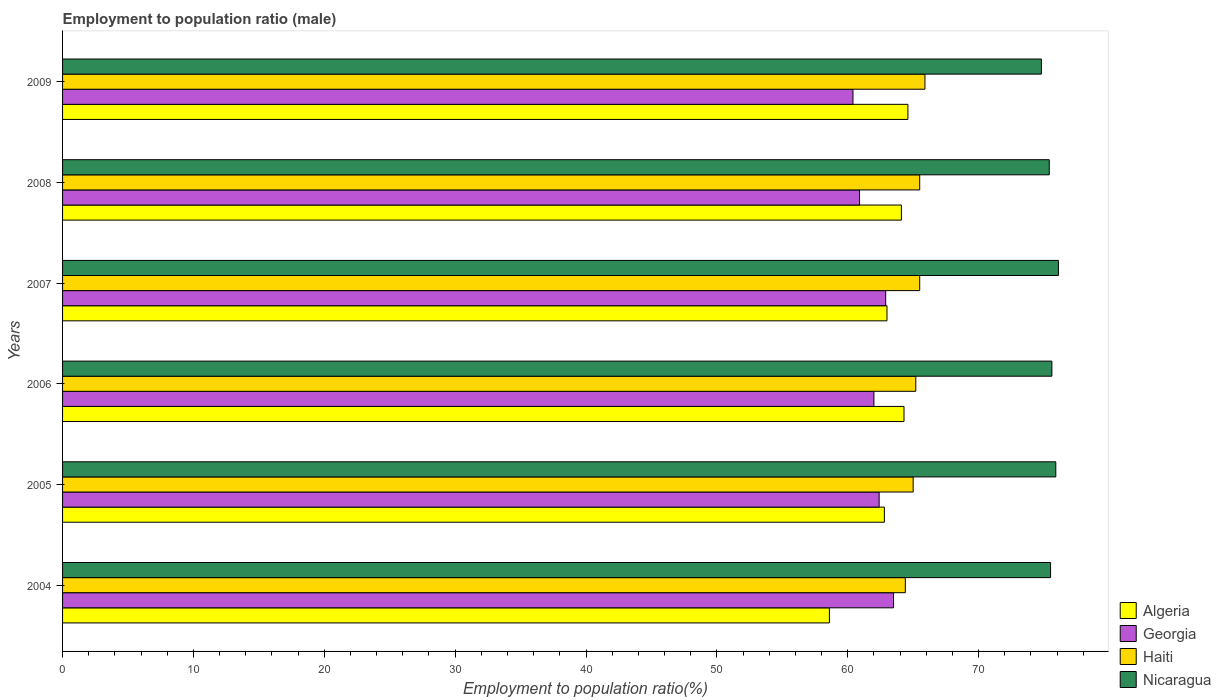How many different coloured bars are there?
Provide a short and direct response. 4. Are the number of bars per tick equal to the number of legend labels?
Ensure brevity in your answer.  Yes. What is the label of the 2nd group of bars from the top?
Make the answer very short. 2008. What is the employment to population ratio in Georgia in 2008?
Keep it short and to the point. 60.9. Across all years, what is the maximum employment to population ratio in Georgia?
Your response must be concise. 63.5. Across all years, what is the minimum employment to population ratio in Haiti?
Ensure brevity in your answer.  64.4. In which year was the employment to population ratio in Haiti maximum?
Ensure brevity in your answer.  2009. In which year was the employment to population ratio in Georgia minimum?
Ensure brevity in your answer.  2009. What is the total employment to population ratio in Algeria in the graph?
Make the answer very short. 377.4. What is the difference between the employment to population ratio in Nicaragua in 2004 and that in 2005?
Your answer should be very brief. -0.4. What is the difference between the employment to population ratio in Georgia in 2006 and the employment to population ratio in Nicaragua in 2005?
Keep it short and to the point. -13.9. What is the average employment to population ratio in Haiti per year?
Your response must be concise. 65.25. In the year 2005, what is the difference between the employment to population ratio in Haiti and employment to population ratio in Nicaragua?
Your answer should be very brief. -10.9. What is the ratio of the employment to population ratio in Algeria in 2007 to that in 2009?
Give a very brief answer. 0.98. Is the employment to population ratio in Georgia in 2004 less than that in 2008?
Your answer should be compact. No. Is the difference between the employment to population ratio in Haiti in 2006 and 2009 greater than the difference between the employment to population ratio in Nicaragua in 2006 and 2009?
Your answer should be compact. No. What is the difference between the highest and the second highest employment to population ratio in Haiti?
Your answer should be compact. 0.4. What is the difference between the highest and the lowest employment to population ratio in Georgia?
Your answer should be compact. 3.1. In how many years, is the employment to population ratio in Georgia greater than the average employment to population ratio in Georgia taken over all years?
Your response must be concise. 3. What does the 3rd bar from the top in 2006 represents?
Provide a succinct answer. Georgia. What does the 2nd bar from the bottom in 2007 represents?
Ensure brevity in your answer.  Georgia. Is it the case that in every year, the sum of the employment to population ratio in Haiti and employment to population ratio in Nicaragua is greater than the employment to population ratio in Georgia?
Give a very brief answer. Yes. Are all the bars in the graph horizontal?
Provide a short and direct response. Yes. Are the values on the major ticks of X-axis written in scientific E-notation?
Provide a short and direct response. No. How many legend labels are there?
Your response must be concise. 4. How are the legend labels stacked?
Your answer should be very brief. Vertical. What is the title of the graph?
Offer a very short reply. Employment to population ratio (male). What is the label or title of the X-axis?
Keep it short and to the point. Employment to population ratio(%). What is the label or title of the Y-axis?
Offer a terse response. Years. What is the Employment to population ratio(%) of Algeria in 2004?
Your response must be concise. 58.6. What is the Employment to population ratio(%) in Georgia in 2004?
Offer a very short reply. 63.5. What is the Employment to population ratio(%) of Haiti in 2004?
Ensure brevity in your answer.  64.4. What is the Employment to population ratio(%) of Nicaragua in 2004?
Make the answer very short. 75.5. What is the Employment to population ratio(%) in Algeria in 2005?
Your response must be concise. 62.8. What is the Employment to population ratio(%) of Georgia in 2005?
Offer a very short reply. 62.4. What is the Employment to population ratio(%) of Nicaragua in 2005?
Your answer should be very brief. 75.9. What is the Employment to population ratio(%) of Algeria in 2006?
Provide a succinct answer. 64.3. What is the Employment to population ratio(%) of Georgia in 2006?
Offer a terse response. 62. What is the Employment to population ratio(%) in Haiti in 2006?
Your response must be concise. 65.2. What is the Employment to population ratio(%) in Nicaragua in 2006?
Your answer should be compact. 75.6. What is the Employment to population ratio(%) of Algeria in 2007?
Your response must be concise. 63. What is the Employment to population ratio(%) in Georgia in 2007?
Make the answer very short. 62.9. What is the Employment to population ratio(%) of Haiti in 2007?
Your answer should be compact. 65.5. What is the Employment to population ratio(%) in Nicaragua in 2007?
Your response must be concise. 76.1. What is the Employment to population ratio(%) in Algeria in 2008?
Keep it short and to the point. 64.1. What is the Employment to population ratio(%) in Georgia in 2008?
Provide a short and direct response. 60.9. What is the Employment to population ratio(%) in Haiti in 2008?
Provide a short and direct response. 65.5. What is the Employment to population ratio(%) in Nicaragua in 2008?
Your answer should be very brief. 75.4. What is the Employment to population ratio(%) of Algeria in 2009?
Provide a succinct answer. 64.6. What is the Employment to population ratio(%) of Georgia in 2009?
Make the answer very short. 60.4. What is the Employment to population ratio(%) in Haiti in 2009?
Ensure brevity in your answer.  65.9. What is the Employment to population ratio(%) in Nicaragua in 2009?
Provide a succinct answer. 74.8. Across all years, what is the maximum Employment to population ratio(%) in Algeria?
Your response must be concise. 64.6. Across all years, what is the maximum Employment to population ratio(%) in Georgia?
Keep it short and to the point. 63.5. Across all years, what is the maximum Employment to population ratio(%) of Haiti?
Ensure brevity in your answer.  65.9. Across all years, what is the maximum Employment to population ratio(%) in Nicaragua?
Keep it short and to the point. 76.1. Across all years, what is the minimum Employment to population ratio(%) of Algeria?
Provide a succinct answer. 58.6. Across all years, what is the minimum Employment to population ratio(%) in Georgia?
Your answer should be very brief. 60.4. Across all years, what is the minimum Employment to population ratio(%) in Haiti?
Give a very brief answer. 64.4. Across all years, what is the minimum Employment to population ratio(%) in Nicaragua?
Offer a terse response. 74.8. What is the total Employment to population ratio(%) in Algeria in the graph?
Provide a succinct answer. 377.4. What is the total Employment to population ratio(%) of Georgia in the graph?
Give a very brief answer. 372.1. What is the total Employment to population ratio(%) of Haiti in the graph?
Your answer should be compact. 391.5. What is the total Employment to population ratio(%) in Nicaragua in the graph?
Give a very brief answer. 453.3. What is the difference between the Employment to population ratio(%) in Georgia in 2004 and that in 2005?
Ensure brevity in your answer.  1.1. What is the difference between the Employment to population ratio(%) in Nicaragua in 2004 and that in 2005?
Make the answer very short. -0.4. What is the difference between the Employment to population ratio(%) in Haiti in 2004 and that in 2006?
Provide a short and direct response. -0.8. What is the difference between the Employment to population ratio(%) in Nicaragua in 2004 and that in 2006?
Your answer should be compact. -0.1. What is the difference between the Employment to population ratio(%) of Algeria in 2004 and that in 2008?
Give a very brief answer. -5.5. What is the difference between the Employment to population ratio(%) of Georgia in 2004 and that in 2009?
Keep it short and to the point. 3.1. What is the difference between the Employment to population ratio(%) in Haiti in 2004 and that in 2009?
Offer a terse response. -1.5. What is the difference between the Employment to population ratio(%) in Nicaragua in 2004 and that in 2009?
Offer a very short reply. 0.7. What is the difference between the Employment to population ratio(%) of Nicaragua in 2005 and that in 2006?
Provide a short and direct response. 0.3. What is the difference between the Employment to population ratio(%) in Algeria in 2005 and that in 2008?
Offer a very short reply. -1.3. What is the difference between the Employment to population ratio(%) of Algeria in 2005 and that in 2009?
Keep it short and to the point. -1.8. What is the difference between the Employment to population ratio(%) in Georgia in 2006 and that in 2007?
Provide a succinct answer. -0.9. What is the difference between the Employment to population ratio(%) of Haiti in 2006 and that in 2007?
Your response must be concise. -0.3. What is the difference between the Employment to population ratio(%) in Nicaragua in 2006 and that in 2007?
Make the answer very short. -0.5. What is the difference between the Employment to population ratio(%) in Haiti in 2006 and that in 2008?
Offer a terse response. -0.3. What is the difference between the Employment to population ratio(%) in Algeria in 2006 and that in 2009?
Your answer should be compact. -0.3. What is the difference between the Employment to population ratio(%) of Haiti in 2006 and that in 2009?
Keep it short and to the point. -0.7. What is the difference between the Employment to population ratio(%) of Nicaragua in 2006 and that in 2009?
Keep it short and to the point. 0.8. What is the difference between the Employment to population ratio(%) of Georgia in 2007 and that in 2008?
Your answer should be compact. 2. What is the difference between the Employment to population ratio(%) of Georgia in 2007 and that in 2009?
Offer a very short reply. 2.5. What is the difference between the Employment to population ratio(%) of Haiti in 2007 and that in 2009?
Offer a very short reply. -0.4. What is the difference between the Employment to population ratio(%) of Nicaragua in 2007 and that in 2009?
Give a very brief answer. 1.3. What is the difference between the Employment to population ratio(%) in Algeria in 2008 and that in 2009?
Provide a succinct answer. -0.5. What is the difference between the Employment to population ratio(%) of Georgia in 2008 and that in 2009?
Offer a terse response. 0.5. What is the difference between the Employment to population ratio(%) of Nicaragua in 2008 and that in 2009?
Offer a terse response. 0.6. What is the difference between the Employment to population ratio(%) in Algeria in 2004 and the Employment to population ratio(%) in Nicaragua in 2005?
Ensure brevity in your answer.  -17.3. What is the difference between the Employment to population ratio(%) of Algeria in 2004 and the Employment to population ratio(%) of Georgia in 2006?
Make the answer very short. -3.4. What is the difference between the Employment to population ratio(%) of Algeria in 2004 and the Employment to population ratio(%) of Haiti in 2006?
Your answer should be compact. -6.6. What is the difference between the Employment to population ratio(%) of Georgia in 2004 and the Employment to population ratio(%) of Nicaragua in 2006?
Offer a terse response. -12.1. What is the difference between the Employment to population ratio(%) in Algeria in 2004 and the Employment to population ratio(%) in Haiti in 2007?
Make the answer very short. -6.9. What is the difference between the Employment to population ratio(%) of Algeria in 2004 and the Employment to population ratio(%) of Nicaragua in 2007?
Ensure brevity in your answer.  -17.5. What is the difference between the Employment to population ratio(%) of Georgia in 2004 and the Employment to population ratio(%) of Haiti in 2007?
Your response must be concise. -2. What is the difference between the Employment to population ratio(%) in Haiti in 2004 and the Employment to population ratio(%) in Nicaragua in 2007?
Ensure brevity in your answer.  -11.7. What is the difference between the Employment to population ratio(%) of Algeria in 2004 and the Employment to population ratio(%) of Nicaragua in 2008?
Provide a succinct answer. -16.8. What is the difference between the Employment to population ratio(%) of Georgia in 2004 and the Employment to population ratio(%) of Haiti in 2008?
Ensure brevity in your answer.  -2. What is the difference between the Employment to population ratio(%) in Georgia in 2004 and the Employment to population ratio(%) in Nicaragua in 2008?
Make the answer very short. -11.9. What is the difference between the Employment to population ratio(%) in Algeria in 2004 and the Employment to population ratio(%) in Haiti in 2009?
Keep it short and to the point. -7.3. What is the difference between the Employment to population ratio(%) of Algeria in 2004 and the Employment to population ratio(%) of Nicaragua in 2009?
Make the answer very short. -16.2. What is the difference between the Employment to population ratio(%) in Georgia in 2004 and the Employment to population ratio(%) in Nicaragua in 2009?
Make the answer very short. -11.3. What is the difference between the Employment to population ratio(%) of Georgia in 2005 and the Employment to population ratio(%) of Haiti in 2006?
Offer a terse response. -2.8. What is the difference between the Employment to population ratio(%) in Georgia in 2005 and the Employment to population ratio(%) in Nicaragua in 2006?
Your response must be concise. -13.2. What is the difference between the Employment to population ratio(%) in Georgia in 2005 and the Employment to population ratio(%) in Haiti in 2007?
Keep it short and to the point. -3.1. What is the difference between the Employment to population ratio(%) of Georgia in 2005 and the Employment to population ratio(%) of Nicaragua in 2007?
Ensure brevity in your answer.  -13.7. What is the difference between the Employment to population ratio(%) in Haiti in 2005 and the Employment to population ratio(%) in Nicaragua in 2007?
Offer a terse response. -11.1. What is the difference between the Employment to population ratio(%) of Algeria in 2005 and the Employment to population ratio(%) of Georgia in 2008?
Offer a terse response. 1.9. What is the difference between the Employment to population ratio(%) in Algeria in 2005 and the Employment to population ratio(%) in Haiti in 2008?
Offer a terse response. -2.7. What is the difference between the Employment to population ratio(%) of Algeria in 2005 and the Employment to population ratio(%) of Nicaragua in 2008?
Provide a short and direct response. -12.6. What is the difference between the Employment to population ratio(%) in Georgia in 2005 and the Employment to population ratio(%) in Haiti in 2008?
Offer a very short reply. -3.1. What is the difference between the Employment to population ratio(%) in Georgia in 2005 and the Employment to population ratio(%) in Nicaragua in 2008?
Your answer should be very brief. -13. What is the difference between the Employment to population ratio(%) in Haiti in 2005 and the Employment to population ratio(%) in Nicaragua in 2008?
Your answer should be compact. -10.4. What is the difference between the Employment to population ratio(%) in Algeria in 2005 and the Employment to population ratio(%) in Georgia in 2009?
Your answer should be compact. 2.4. What is the difference between the Employment to population ratio(%) in Algeria in 2005 and the Employment to population ratio(%) in Haiti in 2009?
Provide a short and direct response. -3.1. What is the difference between the Employment to population ratio(%) of Georgia in 2005 and the Employment to population ratio(%) of Nicaragua in 2009?
Provide a succinct answer. -12.4. What is the difference between the Employment to population ratio(%) in Algeria in 2006 and the Employment to population ratio(%) in Georgia in 2007?
Offer a very short reply. 1.4. What is the difference between the Employment to population ratio(%) in Algeria in 2006 and the Employment to population ratio(%) in Nicaragua in 2007?
Offer a very short reply. -11.8. What is the difference between the Employment to population ratio(%) of Georgia in 2006 and the Employment to population ratio(%) of Haiti in 2007?
Provide a succinct answer. -3.5. What is the difference between the Employment to population ratio(%) in Georgia in 2006 and the Employment to population ratio(%) in Nicaragua in 2007?
Ensure brevity in your answer.  -14.1. What is the difference between the Employment to population ratio(%) in Haiti in 2006 and the Employment to population ratio(%) in Nicaragua in 2007?
Ensure brevity in your answer.  -10.9. What is the difference between the Employment to population ratio(%) in Algeria in 2006 and the Employment to population ratio(%) in Georgia in 2008?
Your answer should be very brief. 3.4. What is the difference between the Employment to population ratio(%) of Algeria in 2006 and the Employment to population ratio(%) of Nicaragua in 2008?
Provide a short and direct response. -11.1. What is the difference between the Employment to population ratio(%) of Georgia in 2006 and the Employment to population ratio(%) of Haiti in 2008?
Your response must be concise. -3.5. What is the difference between the Employment to population ratio(%) of Georgia in 2006 and the Employment to population ratio(%) of Nicaragua in 2008?
Your response must be concise. -13.4. What is the difference between the Employment to population ratio(%) of Georgia in 2006 and the Employment to population ratio(%) of Nicaragua in 2009?
Make the answer very short. -12.8. What is the difference between the Employment to population ratio(%) of Haiti in 2006 and the Employment to population ratio(%) of Nicaragua in 2009?
Ensure brevity in your answer.  -9.6. What is the difference between the Employment to population ratio(%) in Algeria in 2007 and the Employment to population ratio(%) in Georgia in 2008?
Keep it short and to the point. 2.1. What is the difference between the Employment to population ratio(%) in Algeria in 2007 and the Employment to population ratio(%) in Haiti in 2008?
Your response must be concise. -2.5. What is the difference between the Employment to population ratio(%) of Algeria in 2007 and the Employment to population ratio(%) of Nicaragua in 2008?
Provide a short and direct response. -12.4. What is the difference between the Employment to population ratio(%) in Georgia in 2007 and the Employment to population ratio(%) in Haiti in 2008?
Make the answer very short. -2.6. What is the difference between the Employment to population ratio(%) of Haiti in 2007 and the Employment to population ratio(%) of Nicaragua in 2008?
Provide a succinct answer. -9.9. What is the difference between the Employment to population ratio(%) of Algeria in 2007 and the Employment to population ratio(%) of Haiti in 2009?
Give a very brief answer. -2.9. What is the difference between the Employment to population ratio(%) of Algeria in 2007 and the Employment to population ratio(%) of Nicaragua in 2009?
Offer a terse response. -11.8. What is the difference between the Employment to population ratio(%) in Georgia in 2007 and the Employment to population ratio(%) in Haiti in 2009?
Offer a terse response. -3. What is the difference between the Employment to population ratio(%) of Georgia in 2007 and the Employment to population ratio(%) of Nicaragua in 2009?
Give a very brief answer. -11.9. What is the difference between the Employment to population ratio(%) in Georgia in 2008 and the Employment to population ratio(%) in Haiti in 2009?
Provide a succinct answer. -5. What is the difference between the Employment to population ratio(%) in Georgia in 2008 and the Employment to population ratio(%) in Nicaragua in 2009?
Offer a terse response. -13.9. What is the average Employment to population ratio(%) in Algeria per year?
Give a very brief answer. 62.9. What is the average Employment to population ratio(%) of Georgia per year?
Make the answer very short. 62.02. What is the average Employment to population ratio(%) in Haiti per year?
Your answer should be very brief. 65.25. What is the average Employment to population ratio(%) in Nicaragua per year?
Keep it short and to the point. 75.55. In the year 2004, what is the difference between the Employment to population ratio(%) of Algeria and Employment to population ratio(%) of Georgia?
Offer a terse response. -4.9. In the year 2004, what is the difference between the Employment to population ratio(%) in Algeria and Employment to population ratio(%) in Nicaragua?
Provide a succinct answer. -16.9. In the year 2004, what is the difference between the Employment to population ratio(%) of Georgia and Employment to population ratio(%) of Nicaragua?
Offer a terse response. -12. In the year 2005, what is the difference between the Employment to population ratio(%) in Algeria and Employment to population ratio(%) in Haiti?
Your response must be concise. -2.2. In the year 2005, what is the difference between the Employment to population ratio(%) of Algeria and Employment to population ratio(%) of Nicaragua?
Make the answer very short. -13.1. In the year 2005, what is the difference between the Employment to population ratio(%) in Georgia and Employment to population ratio(%) in Haiti?
Provide a short and direct response. -2.6. In the year 2005, what is the difference between the Employment to population ratio(%) in Georgia and Employment to population ratio(%) in Nicaragua?
Ensure brevity in your answer.  -13.5. In the year 2006, what is the difference between the Employment to population ratio(%) in Algeria and Employment to population ratio(%) in Georgia?
Keep it short and to the point. 2.3. In the year 2006, what is the difference between the Employment to population ratio(%) in Algeria and Employment to population ratio(%) in Haiti?
Offer a terse response. -0.9. In the year 2006, what is the difference between the Employment to population ratio(%) in Algeria and Employment to population ratio(%) in Nicaragua?
Provide a short and direct response. -11.3. In the year 2006, what is the difference between the Employment to population ratio(%) of Georgia and Employment to population ratio(%) of Nicaragua?
Ensure brevity in your answer.  -13.6. In the year 2007, what is the difference between the Employment to population ratio(%) of Algeria and Employment to population ratio(%) of Georgia?
Offer a very short reply. 0.1. In the year 2007, what is the difference between the Employment to population ratio(%) of Algeria and Employment to population ratio(%) of Haiti?
Offer a very short reply. -2.5. In the year 2007, what is the difference between the Employment to population ratio(%) of Algeria and Employment to population ratio(%) of Nicaragua?
Ensure brevity in your answer.  -13.1. In the year 2007, what is the difference between the Employment to population ratio(%) in Georgia and Employment to population ratio(%) in Haiti?
Offer a very short reply. -2.6. In the year 2007, what is the difference between the Employment to population ratio(%) of Haiti and Employment to population ratio(%) of Nicaragua?
Your answer should be compact. -10.6. In the year 2008, what is the difference between the Employment to population ratio(%) of Georgia and Employment to population ratio(%) of Nicaragua?
Keep it short and to the point. -14.5. In the year 2008, what is the difference between the Employment to population ratio(%) of Haiti and Employment to population ratio(%) of Nicaragua?
Ensure brevity in your answer.  -9.9. In the year 2009, what is the difference between the Employment to population ratio(%) in Algeria and Employment to population ratio(%) in Georgia?
Ensure brevity in your answer.  4.2. In the year 2009, what is the difference between the Employment to population ratio(%) of Algeria and Employment to population ratio(%) of Haiti?
Give a very brief answer. -1.3. In the year 2009, what is the difference between the Employment to population ratio(%) of Georgia and Employment to population ratio(%) of Haiti?
Ensure brevity in your answer.  -5.5. In the year 2009, what is the difference between the Employment to population ratio(%) of Georgia and Employment to population ratio(%) of Nicaragua?
Ensure brevity in your answer.  -14.4. In the year 2009, what is the difference between the Employment to population ratio(%) of Haiti and Employment to population ratio(%) of Nicaragua?
Your answer should be very brief. -8.9. What is the ratio of the Employment to population ratio(%) of Algeria in 2004 to that in 2005?
Your answer should be very brief. 0.93. What is the ratio of the Employment to population ratio(%) of Georgia in 2004 to that in 2005?
Provide a short and direct response. 1.02. What is the ratio of the Employment to population ratio(%) in Nicaragua in 2004 to that in 2005?
Offer a terse response. 0.99. What is the ratio of the Employment to population ratio(%) of Algeria in 2004 to that in 2006?
Your answer should be very brief. 0.91. What is the ratio of the Employment to population ratio(%) of Georgia in 2004 to that in 2006?
Provide a short and direct response. 1.02. What is the ratio of the Employment to population ratio(%) of Haiti in 2004 to that in 2006?
Make the answer very short. 0.99. What is the ratio of the Employment to population ratio(%) of Algeria in 2004 to that in 2007?
Ensure brevity in your answer.  0.93. What is the ratio of the Employment to population ratio(%) in Georgia in 2004 to that in 2007?
Your answer should be very brief. 1.01. What is the ratio of the Employment to population ratio(%) of Haiti in 2004 to that in 2007?
Your answer should be very brief. 0.98. What is the ratio of the Employment to population ratio(%) of Nicaragua in 2004 to that in 2007?
Offer a very short reply. 0.99. What is the ratio of the Employment to population ratio(%) in Algeria in 2004 to that in 2008?
Your response must be concise. 0.91. What is the ratio of the Employment to population ratio(%) of Georgia in 2004 to that in 2008?
Give a very brief answer. 1.04. What is the ratio of the Employment to population ratio(%) in Haiti in 2004 to that in 2008?
Keep it short and to the point. 0.98. What is the ratio of the Employment to population ratio(%) of Algeria in 2004 to that in 2009?
Make the answer very short. 0.91. What is the ratio of the Employment to population ratio(%) in Georgia in 2004 to that in 2009?
Provide a short and direct response. 1.05. What is the ratio of the Employment to population ratio(%) of Haiti in 2004 to that in 2009?
Your answer should be very brief. 0.98. What is the ratio of the Employment to population ratio(%) in Nicaragua in 2004 to that in 2009?
Keep it short and to the point. 1.01. What is the ratio of the Employment to population ratio(%) of Algeria in 2005 to that in 2006?
Ensure brevity in your answer.  0.98. What is the ratio of the Employment to population ratio(%) in Nicaragua in 2005 to that in 2006?
Provide a succinct answer. 1. What is the ratio of the Employment to population ratio(%) of Haiti in 2005 to that in 2007?
Ensure brevity in your answer.  0.99. What is the ratio of the Employment to population ratio(%) in Nicaragua in 2005 to that in 2007?
Provide a short and direct response. 1. What is the ratio of the Employment to population ratio(%) of Algeria in 2005 to that in 2008?
Offer a very short reply. 0.98. What is the ratio of the Employment to population ratio(%) in Georgia in 2005 to that in 2008?
Your answer should be compact. 1.02. What is the ratio of the Employment to population ratio(%) in Haiti in 2005 to that in 2008?
Keep it short and to the point. 0.99. What is the ratio of the Employment to population ratio(%) in Nicaragua in 2005 to that in 2008?
Keep it short and to the point. 1.01. What is the ratio of the Employment to population ratio(%) in Algeria in 2005 to that in 2009?
Ensure brevity in your answer.  0.97. What is the ratio of the Employment to population ratio(%) of Georgia in 2005 to that in 2009?
Give a very brief answer. 1.03. What is the ratio of the Employment to population ratio(%) of Haiti in 2005 to that in 2009?
Provide a succinct answer. 0.99. What is the ratio of the Employment to population ratio(%) in Nicaragua in 2005 to that in 2009?
Offer a very short reply. 1.01. What is the ratio of the Employment to population ratio(%) in Algeria in 2006 to that in 2007?
Make the answer very short. 1.02. What is the ratio of the Employment to population ratio(%) of Georgia in 2006 to that in 2007?
Your answer should be very brief. 0.99. What is the ratio of the Employment to population ratio(%) in Georgia in 2006 to that in 2008?
Your response must be concise. 1.02. What is the ratio of the Employment to population ratio(%) of Nicaragua in 2006 to that in 2008?
Offer a terse response. 1. What is the ratio of the Employment to population ratio(%) in Algeria in 2006 to that in 2009?
Provide a succinct answer. 1. What is the ratio of the Employment to population ratio(%) of Georgia in 2006 to that in 2009?
Your answer should be compact. 1.03. What is the ratio of the Employment to population ratio(%) of Nicaragua in 2006 to that in 2009?
Provide a succinct answer. 1.01. What is the ratio of the Employment to population ratio(%) of Algeria in 2007 to that in 2008?
Give a very brief answer. 0.98. What is the ratio of the Employment to population ratio(%) in Georgia in 2007 to that in 2008?
Your answer should be compact. 1.03. What is the ratio of the Employment to population ratio(%) in Nicaragua in 2007 to that in 2008?
Make the answer very short. 1.01. What is the ratio of the Employment to population ratio(%) in Algeria in 2007 to that in 2009?
Give a very brief answer. 0.98. What is the ratio of the Employment to population ratio(%) in Georgia in 2007 to that in 2009?
Provide a succinct answer. 1.04. What is the ratio of the Employment to population ratio(%) in Nicaragua in 2007 to that in 2009?
Offer a very short reply. 1.02. What is the ratio of the Employment to population ratio(%) of Algeria in 2008 to that in 2009?
Keep it short and to the point. 0.99. What is the ratio of the Employment to population ratio(%) of Georgia in 2008 to that in 2009?
Give a very brief answer. 1.01. What is the ratio of the Employment to population ratio(%) in Haiti in 2008 to that in 2009?
Make the answer very short. 0.99. What is the difference between the highest and the second highest Employment to population ratio(%) in Algeria?
Your response must be concise. 0.3. What is the difference between the highest and the second highest Employment to population ratio(%) in Georgia?
Make the answer very short. 0.6. What is the difference between the highest and the second highest Employment to population ratio(%) of Nicaragua?
Your response must be concise. 0.2. What is the difference between the highest and the lowest Employment to population ratio(%) in Haiti?
Provide a succinct answer. 1.5. What is the difference between the highest and the lowest Employment to population ratio(%) in Nicaragua?
Ensure brevity in your answer.  1.3. 